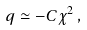<formula> <loc_0><loc_0><loc_500><loc_500>q \simeq - C \chi ^ { 2 } \, ,</formula> 